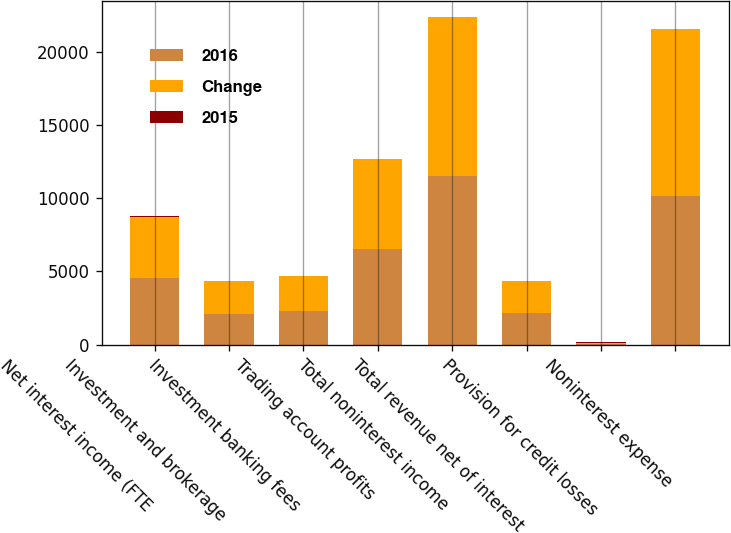Convert chart. <chart><loc_0><loc_0><loc_500><loc_500><stacked_bar_chart><ecel><fcel>Net interest income (FTE<fcel>Investment and brokerage<fcel>Investment banking fees<fcel>Trading account profits<fcel>Total noninterest income<fcel>Total revenue net of interest<fcel>Provision for credit losses<fcel>Noninterest expense<nl><fcel>2016<fcel>4558<fcel>2102<fcel>2296<fcel>6550<fcel>11532<fcel>2161.5<fcel>31<fcel>10170<nl><fcel>Change<fcel>4191<fcel>2221<fcel>2401<fcel>6109<fcel>10822<fcel>2161.5<fcel>99<fcel>11374<nl><fcel>2015<fcel>9<fcel>5<fcel>4<fcel>7<fcel>7<fcel>7<fcel>69<fcel>11<nl></chart> 